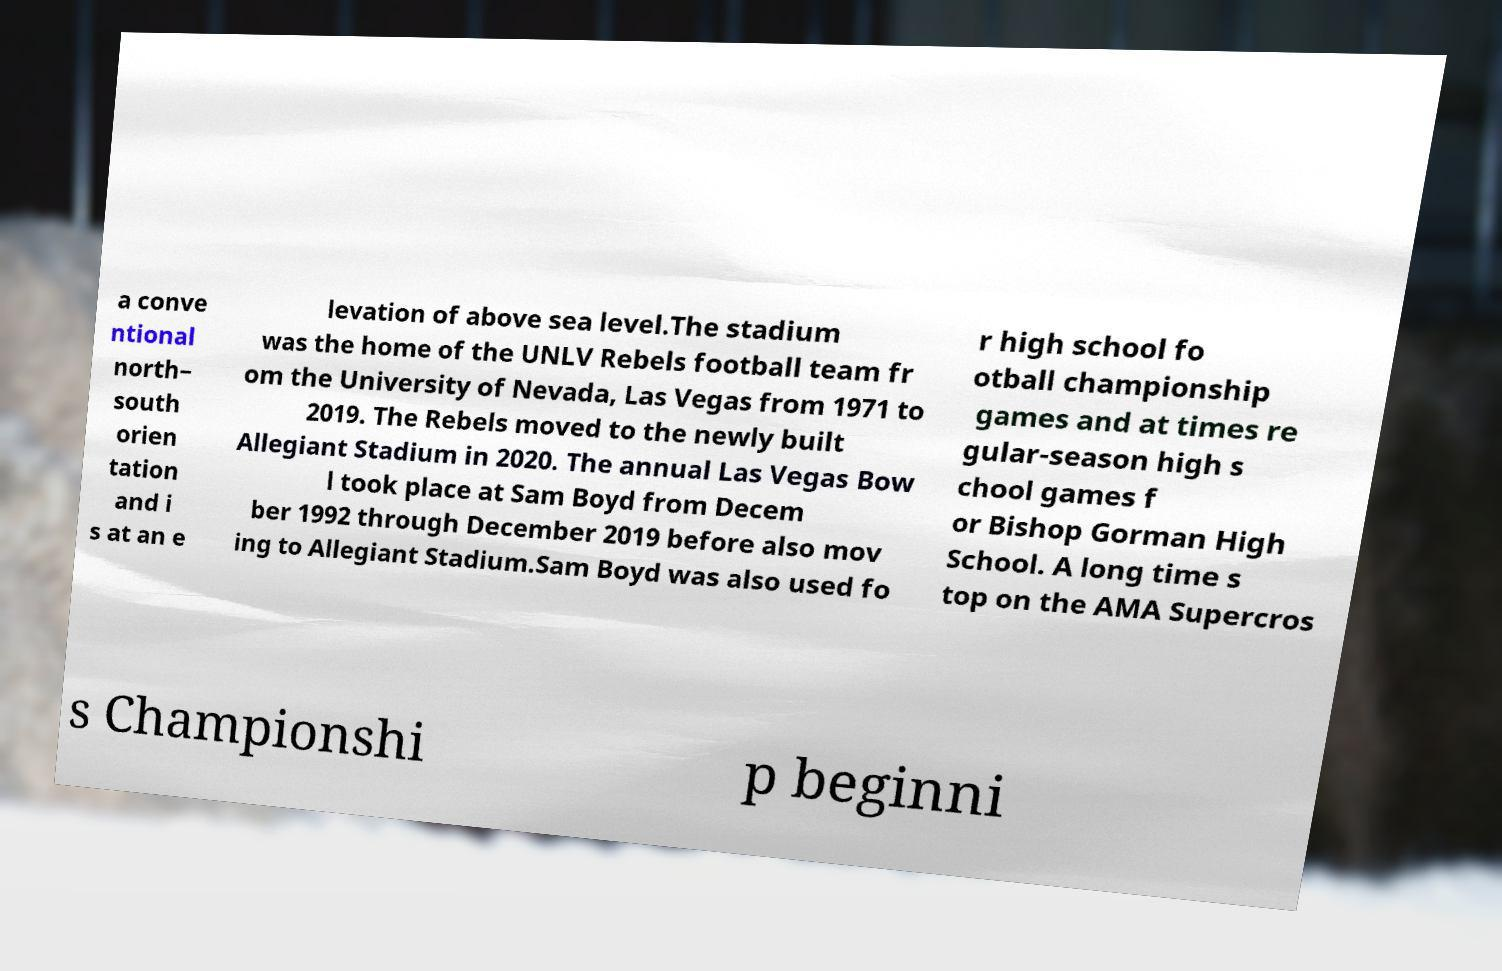Please identify and transcribe the text found in this image. a conve ntional north– south orien tation and i s at an e levation of above sea level.The stadium was the home of the UNLV Rebels football team fr om the University of Nevada, Las Vegas from 1971 to 2019. The Rebels moved to the newly built Allegiant Stadium in 2020. The annual Las Vegas Bow l took place at Sam Boyd from Decem ber 1992 through December 2019 before also mov ing to Allegiant Stadium.Sam Boyd was also used fo r high school fo otball championship games and at times re gular-season high s chool games f or Bishop Gorman High School. A long time s top on the AMA Supercros s Championshi p beginni 